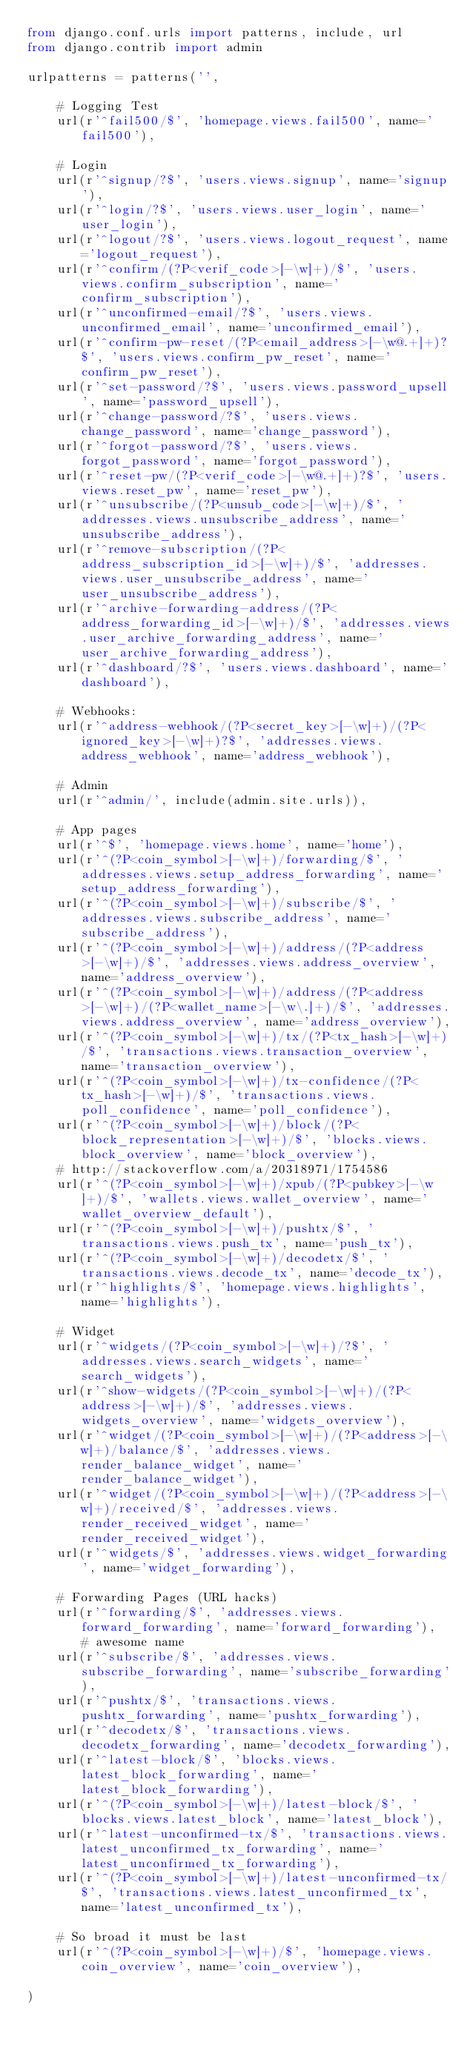<code> <loc_0><loc_0><loc_500><loc_500><_Python_>from django.conf.urls import patterns, include, url
from django.contrib import admin

urlpatterns = patterns('',

    # Logging Test
    url(r'^fail500/$', 'homepage.views.fail500', name='fail500'),

    # Login
    url(r'^signup/?$', 'users.views.signup', name='signup'),
    url(r'^login/?$', 'users.views.user_login', name='user_login'),
    url(r'^logout/?$', 'users.views.logout_request', name='logout_request'),
    url(r'^confirm/(?P<verif_code>[-\w]+)/$', 'users.views.confirm_subscription', name='confirm_subscription'),
    url(r'^unconfirmed-email/?$', 'users.views.unconfirmed_email', name='unconfirmed_email'),
    url(r'^confirm-pw-reset/(?P<email_address>[-\w@.+]+)?$', 'users.views.confirm_pw_reset', name='confirm_pw_reset'),
    url(r'^set-password/?$', 'users.views.password_upsell', name='password_upsell'),
    url(r'^change-password/?$', 'users.views.change_password', name='change_password'),
    url(r'^forgot-password/?$', 'users.views.forgot_password', name='forgot_password'),
    url(r'^reset-pw/(?P<verif_code>[-\w@.+]+)?$', 'users.views.reset_pw', name='reset_pw'),
    url(r'^unsubscribe/(?P<unsub_code>[-\w]+)/$', 'addresses.views.unsubscribe_address', name='unsubscribe_address'),
    url(r'^remove-subscription/(?P<address_subscription_id>[-\w]+)/$', 'addresses.views.user_unsubscribe_address', name='user_unsubscribe_address'),
    url(r'^archive-forwarding-address/(?P<address_forwarding_id>[-\w]+)/$', 'addresses.views.user_archive_forwarding_address', name='user_archive_forwarding_address'),
    url(r'^dashboard/?$', 'users.views.dashboard', name='dashboard'),

    # Webhooks:
    url(r'^address-webhook/(?P<secret_key>[-\w]+)/(?P<ignored_key>[-\w]+)?$', 'addresses.views.address_webhook', name='address_webhook'),

    # Admin
    url(r'^admin/', include(admin.site.urls)),

    # App pages
    url(r'^$', 'homepage.views.home', name='home'),
    url(r'^(?P<coin_symbol>[-\w]+)/forwarding/$', 'addresses.views.setup_address_forwarding', name='setup_address_forwarding'),
    url(r'^(?P<coin_symbol>[-\w]+)/subscribe/$', 'addresses.views.subscribe_address', name='subscribe_address'),
    url(r'^(?P<coin_symbol>[-\w]+)/address/(?P<address>[-\w]+)/$', 'addresses.views.address_overview', name='address_overview'),
    url(r'^(?P<coin_symbol>[-\w]+)/address/(?P<address>[-\w]+)/(?P<wallet_name>[-\w\.]+)/$', 'addresses.views.address_overview', name='address_overview'),
    url(r'^(?P<coin_symbol>[-\w]+)/tx/(?P<tx_hash>[-\w]+)/$', 'transactions.views.transaction_overview', name='transaction_overview'),
    url(r'^(?P<coin_symbol>[-\w]+)/tx-confidence/(?P<tx_hash>[-\w]+)/$', 'transactions.views.poll_confidence', name='poll_confidence'),
    url(r'^(?P<coin_symbol>[-\w]+)/block/(?P<block_representation>[-\w]+)/$', 'blocks.views.block_overview', name='block_overview'),
    # http://stackoverflow.com/a/20318971/1754586
    url(r'^(?P<coin_symbol>[-\w]+)/xpub/(?P<pubkey>[-\w]+)/$', 'wallets.views.wallet_overview', name='wallet_overview_default'),
    url(r'^(?P<coin_symbol>[-\w]+)/pushtx/$', 'transactions.views.push_tx', name='push_tx'),
    url(r'^(?P<coin_symbol>[-\w]+)/decodetx/$', 'transactions.views.decode_tx', name='decode_tx'),
    url(r'^highlights/$', 'homepage.views.highlights', name='highlights'),

    # Widget
    url(r'^widgets/(?P<coin_symbol>[-\w]+)/?$', 'addresses.views.search_widgets', name='search_widgets'),
    url(r'^show-widgets/(?P<coin_symbol>[-\w]+)/(?P<address>[-\w]+)/$', 'addresses.views.widgets_overview', name='widgets_overview'),
    url(r'^widget/(?P<coin_symbol>[-\w]+)/(?P<address>[-\w]+)/balance/$', 'addresses.views.render_balance_widget', name='render_balance_widget'),
    url(r'^widget/(?P<coin_symbol>[-\w]+)/(?P<address>[-\w]+)/received/$', 'addresses.views.render_received_widget', name='render_received_widget'),
    url(r'^widgets/$', 'addresses.views.widget_forwarding', name='widget_forwarding'),

    # Forwarding Pages (URL hacks)
    url(r'^forwarding/$', 'addresses.views.forward_forwarding', name='forward_forwarding'),  # awesome name
    url(r'^subscribe/$', 'addresses.views.subscribe_forwarding', name='subscribe_forwarding'),
    url(r'^pushtx/$', 'transactions.views.pushtx_forwarding', name='pushtx_forwarding'),
    url(r'^decodetx/$', 'transactions.views.decodetx_forwarding', name='decodetx_forwarding'),
    url(r'^latest-block/$', 'blocks.views.latest_block_forwarding', name='latest_block_forwarding'),
    url(r'^(?P<coin_symbol>[-\w]+)/latest-block/$', 'blocks.views.latest_block', name='latest_block'),
    url(r'^latest-unconfirmed-tx/$', 'transactions.views.latest_unconfirmed_tx_forwarding', name='latest_unconfirmed_tx_forwarding'),
    url(r'^(?P<coin_symbol>[-\w]+)/latest-unconfirmed-tx/$', 'transactions.views.latest_unconfirmed_tx', name='latest_unconfirmed_tx'),

    # So broad it must be last
    url(r'^(?P<coin_symbol>[-\w]+)/$', 'homepage.views.coin_overview', name='coin_overview'),

)
</code> 